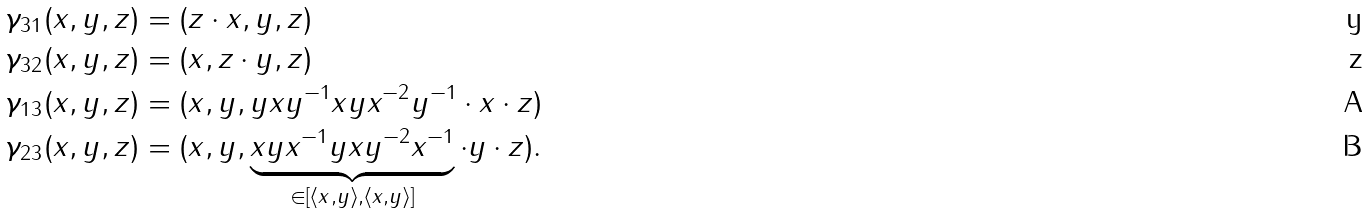Convert formula to latex. <formula><loc_0><loc_0><loc_500><loc_500>\gamma _ { 3 1 } ( x , y , z ) & = ( z \cdot x , y , z ) \\ \gamma _ { 3 2 } ( x , y , z ) & = ( x , z \cdot y , z ) \\ \gamma _ { 1 3 } ( x , y , z ) & = ( x , y , y x y ^ { - 1 } x y x ^ { - 2 } y ^ { - 1 } \cdot x \cdot z ) \\ \gamma _ { 2 3 } ( x , y , z ) & = ( x , y , \underbrace { x y x ^ { - 1 } y x y ^ { - 2 } x ^ { - 1 } } _ { \in [ \langle x , y \rangle , \langle x , y \rangle ] } \cdot y \cdot z ) .</formula> 